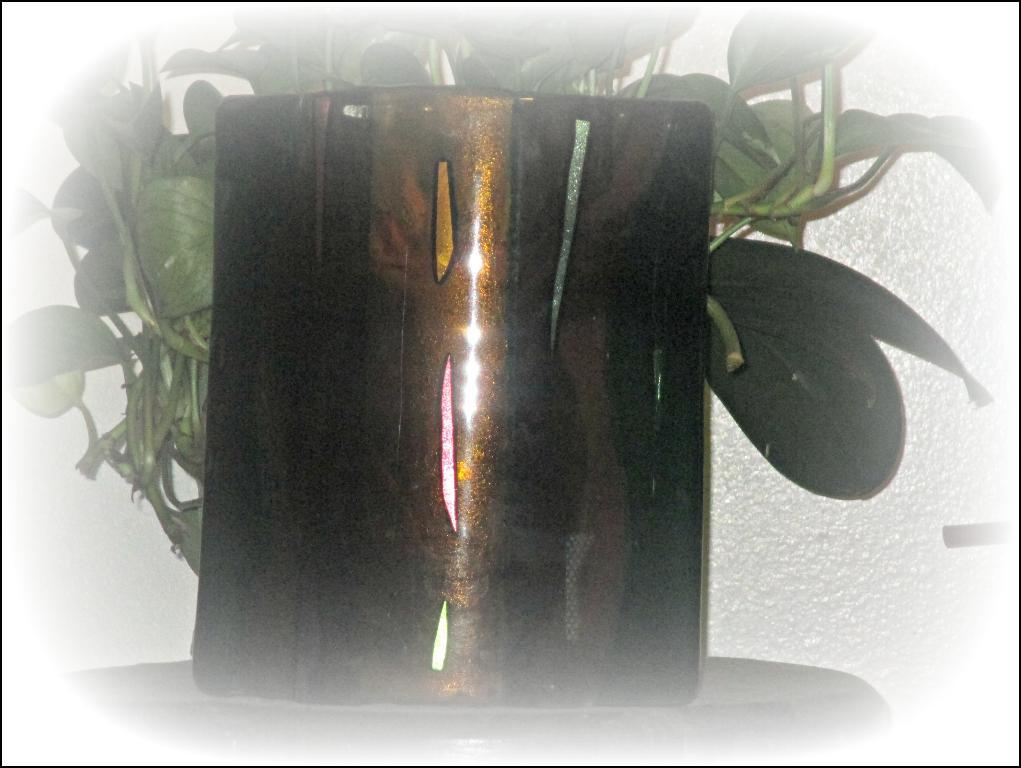What type of living organism is in the image? There is a plant in the image. How is the plant contained or displayed? The plant is in a pot. Where is the pot located? The pot is on a platform. What color is the background of the image? The background of the image appears to be white. What type of song is being sung by the plant in the image? There is no indication in the image that the plant is singing a song, as plants do not have the ability to sing. 